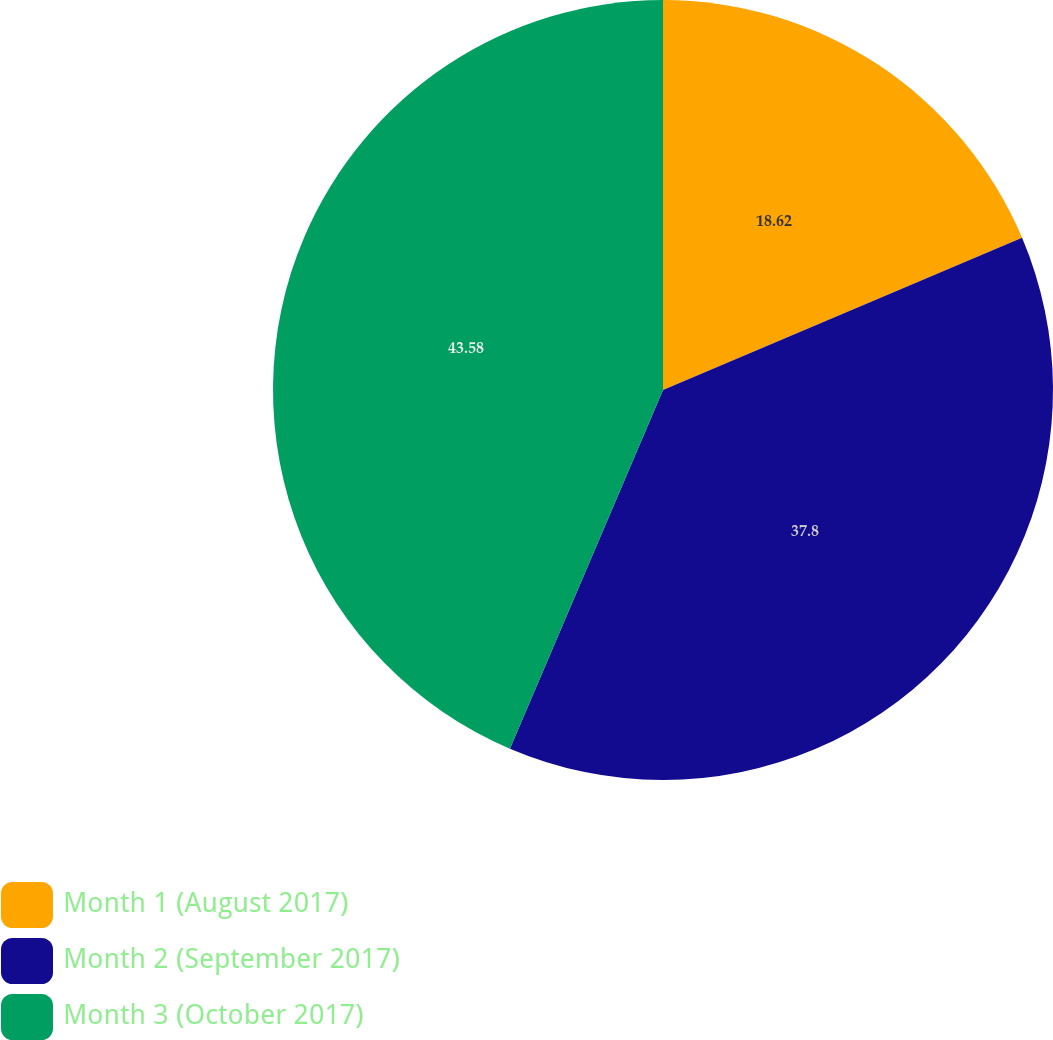<chart> <loc_0><loc_0><loc_500><loc_500><pie_chart><fcel>Month 1 (August 2017)<fcel>Month 2 (September 2017)<fcel>Month 3 (October 2017)<nl><fcel>18.62%<fcel>37.8%<fcel>43.58%<nl></chart> 